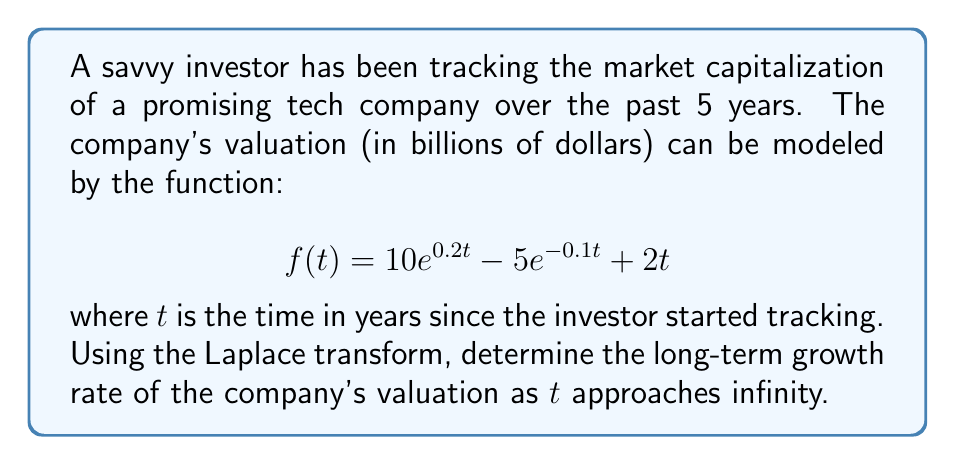Can you solve this math problem? Let's approach this step-by-step using Laplace transforms:

1) First, we need to find the Laplace transform of $f(t)$. Let $F(s)$ be the Laplace transform of $f(t)$:

   $$F(s) = \mathcal{L}\{f(t)\} = \mathcal{L}\{10e^{0.2t}\} - \mathcal{L}\{5e^{-0.1t}\} + \mathcal{L}\{2t\}$$

2) Using Laplace transform properties:
   
   $$F(s) = \frac{10}{s-0.2} - \frac{5}{s+0.1} + \frac{2}{s^2}$$

3) To find the long-term behavior, we need to use the Final Value Theorem:

   $$\lim_{t \to \infty} f(t) = \lim_{s \to 0} sF(s)$$

4) Multiply $F(s)$ by $s$:

   $$sF(s) = \frac{10s}{s-0.2} - \frac{5s}{s+0.1} + \frac{2}{s}$$

5) Now, let's take the limit as $s$ approaches 0:

   $$\lim_{s \to 0} sF(s) = \lim_{s \to 0} (\frac{10s}{s-0.2} - \frac{5s}{s+0.1} + \frac{2}{s})$$

6) Evaluating the limit:
   
   $$= \frac{10 \cdot 0}{0-0.2} - \frac{5 \cdot 0}{0+0.1} + \lim_{s \to 0} \frac{2}{s}$$
   
   $$= 0 - 0 + \infty$$

7) The result is infinity, which means the function grows without bound as $t$ approaches infinity.

8) To find the growth rate, we can look at the dominant term in the original function as $t$ approaches infinity. The term $10e^{0.2t}$ grows faster than the linear term $2t$, and the negative exponential term becomes negligible.

9) Therefore, the long-term growth rate is approximately $0.2$ or 20% per year.
Answer: 20% per year 